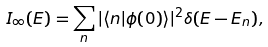<formula> <loc_0><loc_0><loc_500><loc_500>I _ { \infty } ( E ) = \sum _ { n } | \langle n | \phi ( 0 ) \rangle | ^ { 2 } \delta ( E - E _ { n } ) ,</formula> 